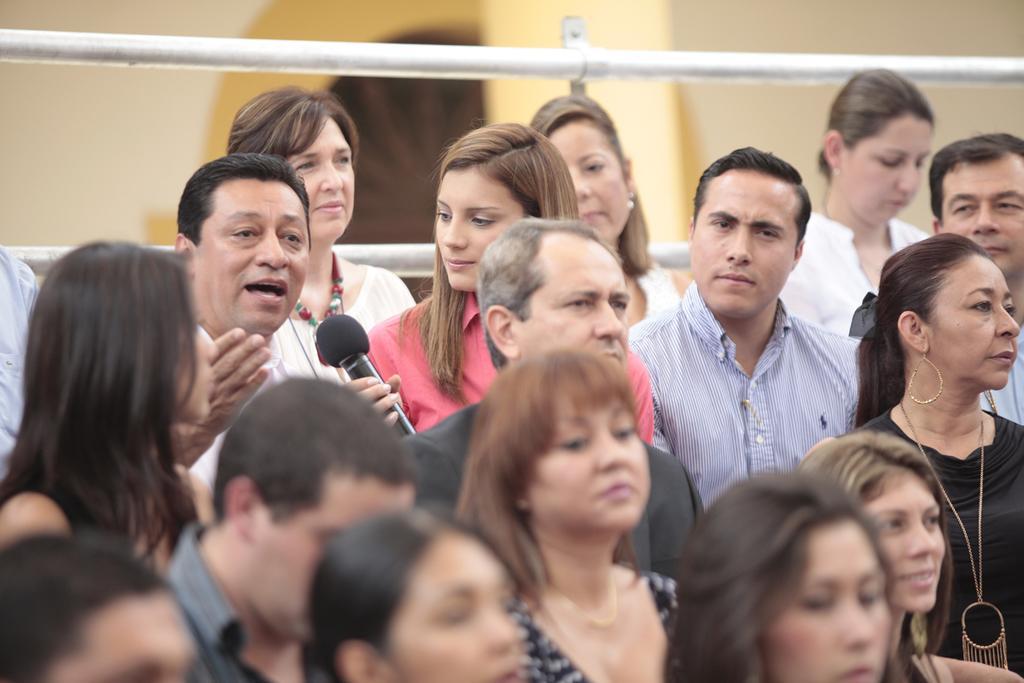Please provide a concise description of this image. In this picture we can see there are groups of people standing and a person is holding a microphone. Behind the people there are rods and a wall. 